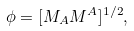<formula> <loc_0><loc_0><loc_500><loc_500>\phi = [ M _ { A } M ^ { A } ] ^ { 1 / 2 } ,</formula> 